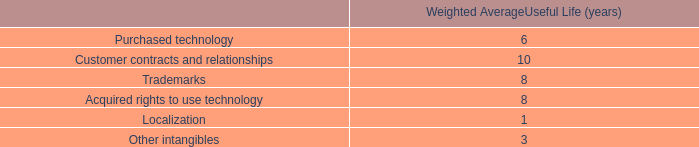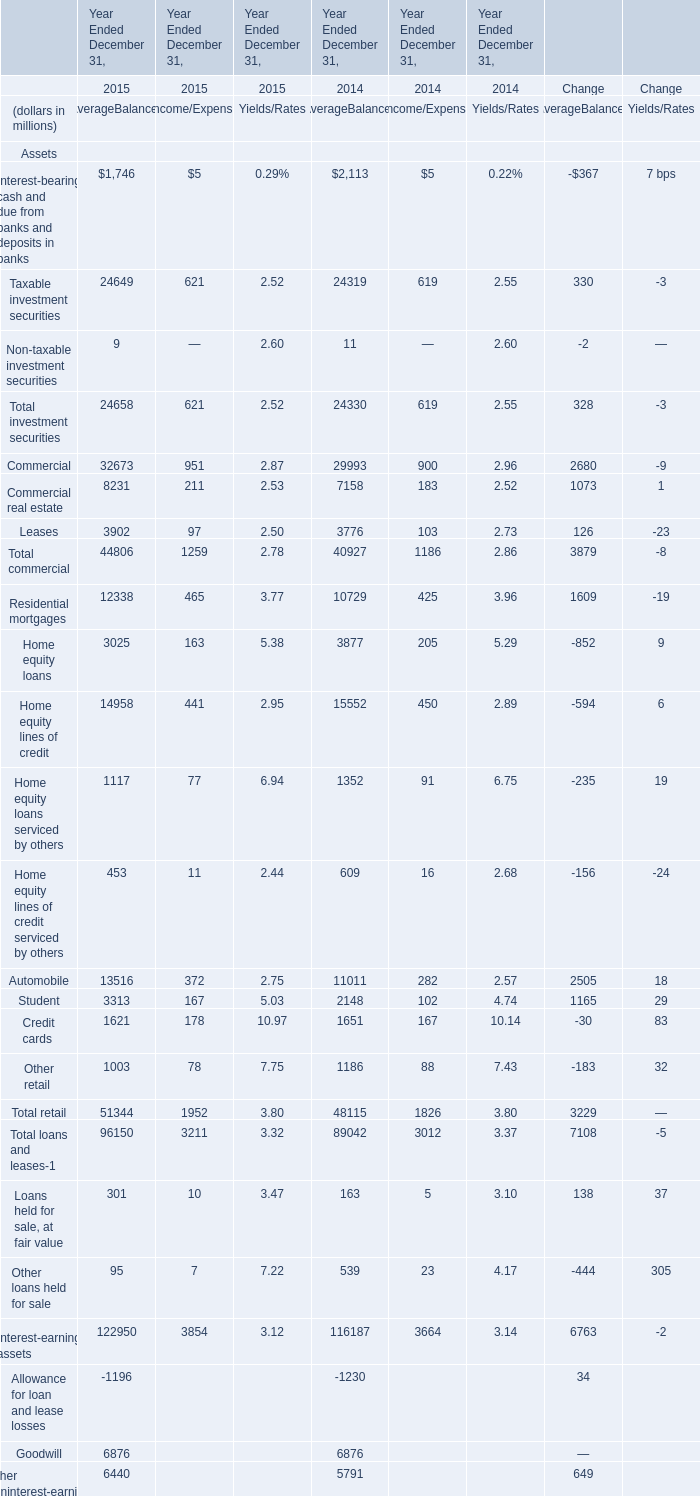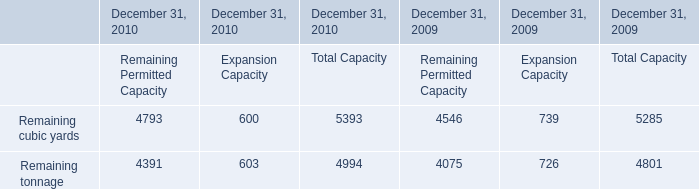What is the total amount of Remaining tonnage of December 31, 2009 Remaining Permitted Capacity, Commercial real estate of Year Ended December 31, 2014 AverageBalances, and Total retail of Year Ended December 31, 2014 Income/Expense ? 
Computations: ((4075.0 + 7158.0) + 1826.0)
Answer: 13059.0. 